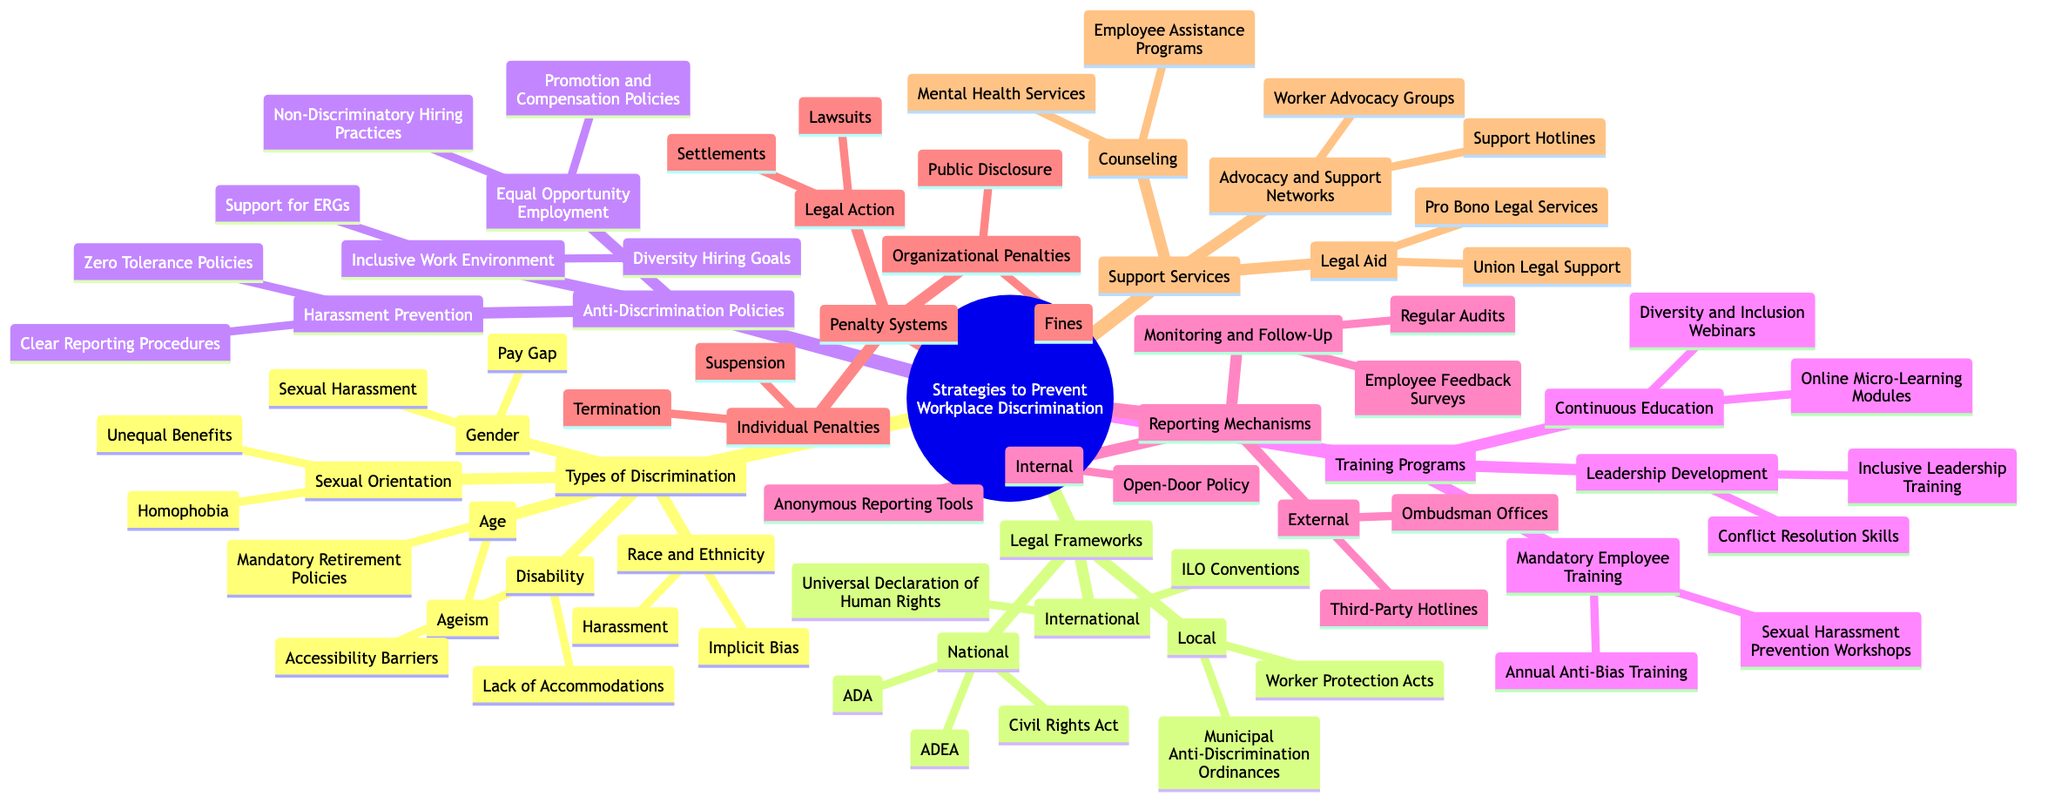What are the two types of discrimination under Gender? The Gender category in the Types of Discrimination node lists two specific types: Pay Gap and Sexual Harassment.
Answer: Pay Gap, Sexual Harassment How many types of discrimination are listed? The Types of Discrimination node contains five distinct categories: Race and Ethnicity, Gender, Age, Disability, and Sexual Orientation, totaling to five.
Answer: 5 What is the legal framework for workplace discrimination at the local level? The Legal Frameworks node outlines Local protections, specifically mentioning Municipal Anti-Discrimination Ordinances and Worker Protection Acts as legal frameworks.
Answer: Municipal Anti-Discrimination Ordinances, Worker Protection Acts Which anti-discrimination policy addresses hiring practices? The Anti-Discrimination Policies node under Equal Opportunity Employment mentions Non-Discriminatory Hiring Practices as a specific policy related to hiring practices.
Answer: Non-Discriminatory Hiring Practices What is one reporting mechanism provided internally? The Reporting Mechanisms node under Internal specifies Anonymous Reporting Tools as one of the mechanisms provided for reporting discrimination.
Answer: Anonymous Reporting Tools How are organizational penalties categorized in the punishment system? The Penalty Systems node categorizes organizational penalties into options like Fines and Public Disclosure, which refer to the penalties applied to organizations.
Answer: Fines, Public Disclosure What training program is mandatory for employees? The Training Programs node lists Mandatory Employee Training, which includes Annual Anti-Bias Training and Sexual Harassment Prevention Workshops, describing what's required for employees.
Answer: Annual Anti-Bias Training, Sexual Harassment Prevention Workshops What type of support service includes mental health services? The Support Services node specifies Counseling as a category that includes Mental Health Services, providing support to employees facing workplace discrimination.
Answer: Mental Health Services What is a specific component of the monitoring and follow-up process in reporting mechanisms? Under Reporting Mechanisms, the Monitoring and Follow-Up category includes Regular Audits and Employee Feedback Surveys, indicating the methods used to ensure effective reporting.
Answer: Regular Audits, Employee Feedback Surveys How many layers of legal frameworks are mentioned? The Legal Frameworks node is subdivided into three distinct layers: International, National, and Local, indicating that there are three layers in total.
Answer: 3 